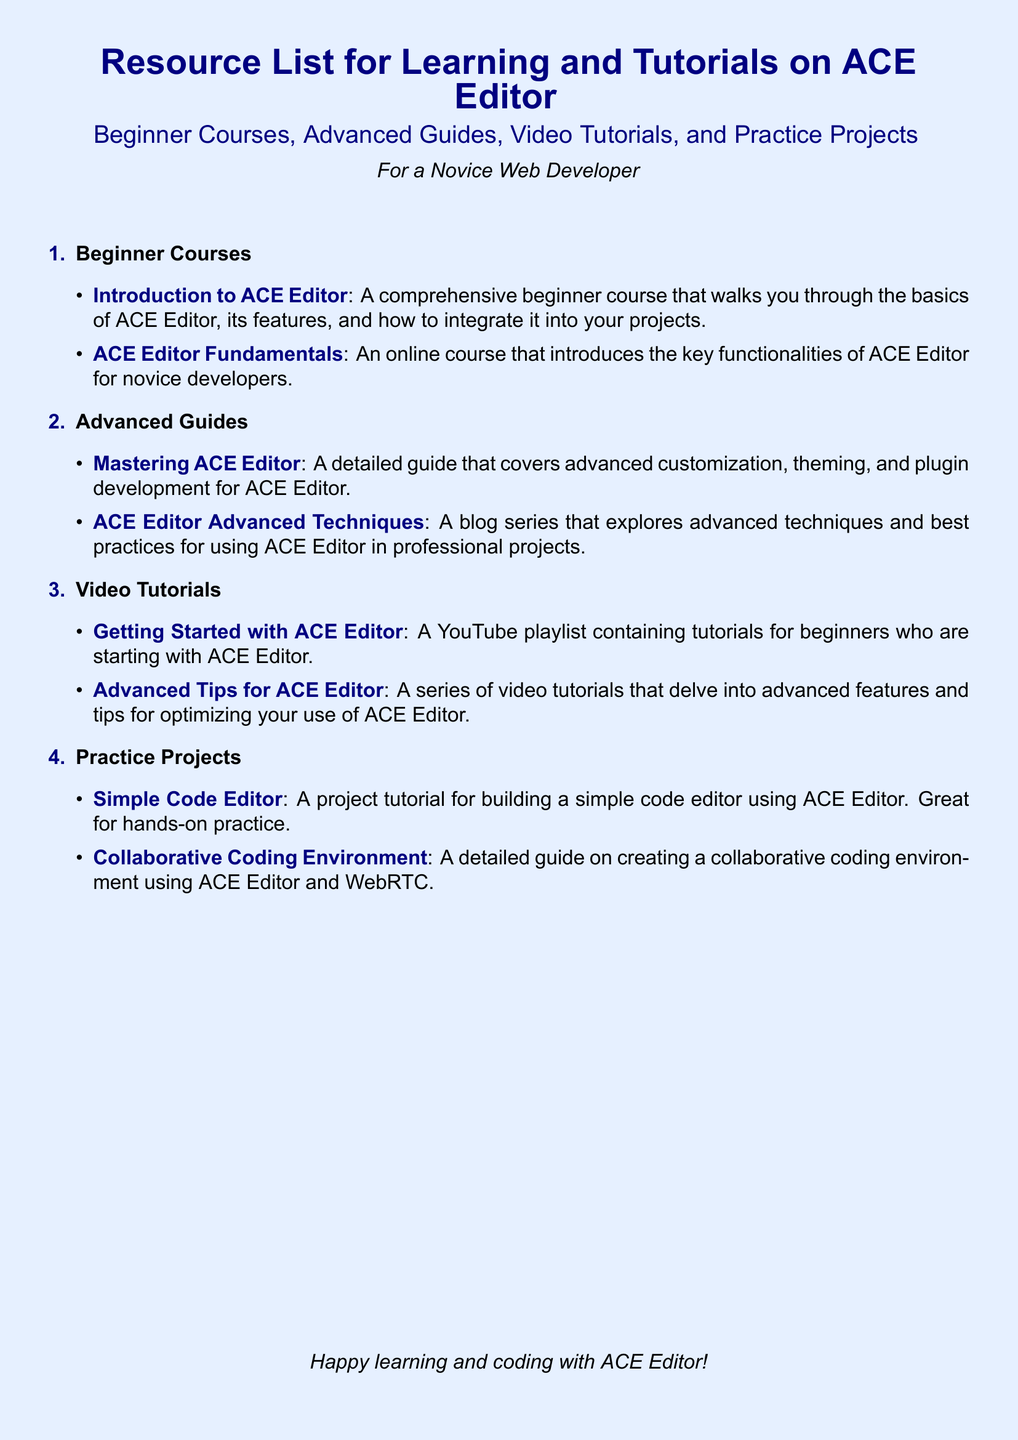What is the title of the document? The title is prominently displayed at the top of the document, indicating the main topic.
Answer: Resource List for Learning and Tutorials on ACE Editor How many main sections are in the document? The document contains four main sections: Beginner Courses, Advanced Guides, Video Tutorials, and Practice Projects.
Answer: 4 Which course is recommended for beginners? The document lists specific courses tailored for beginners, showcasing foundational learning opportunities.
Answer: Introduction to ACE Editor What is the focus of the "Mastering ACE Editor" guide? This guide is specifically mentioned as a resource that deals with more in-depth aspects of ACE Editor.
Answer: Advanced customization, theming, and plugin development How many video tutorials are dedicated to advanced tips? The document includes a specific mention of a series of videos targeting advanced aspects of ACE Editor.
Answer: 1 What kind of project does the "Simple Code Editor" tutorial cover? This project tutorial is aimed at offering hands-on experience with ACE Editor by guiding users through building an editor.
Answer: Simple code editor What is the color theme of the document's background? The document's background features a specific color that sets the visual tone.
Answer: Light blue Which platform offers the "ACE Editor Fundamentals" course? The source of the course is clearly outlined in the document to indicate where learners can enroll.
Answer: Udemy 